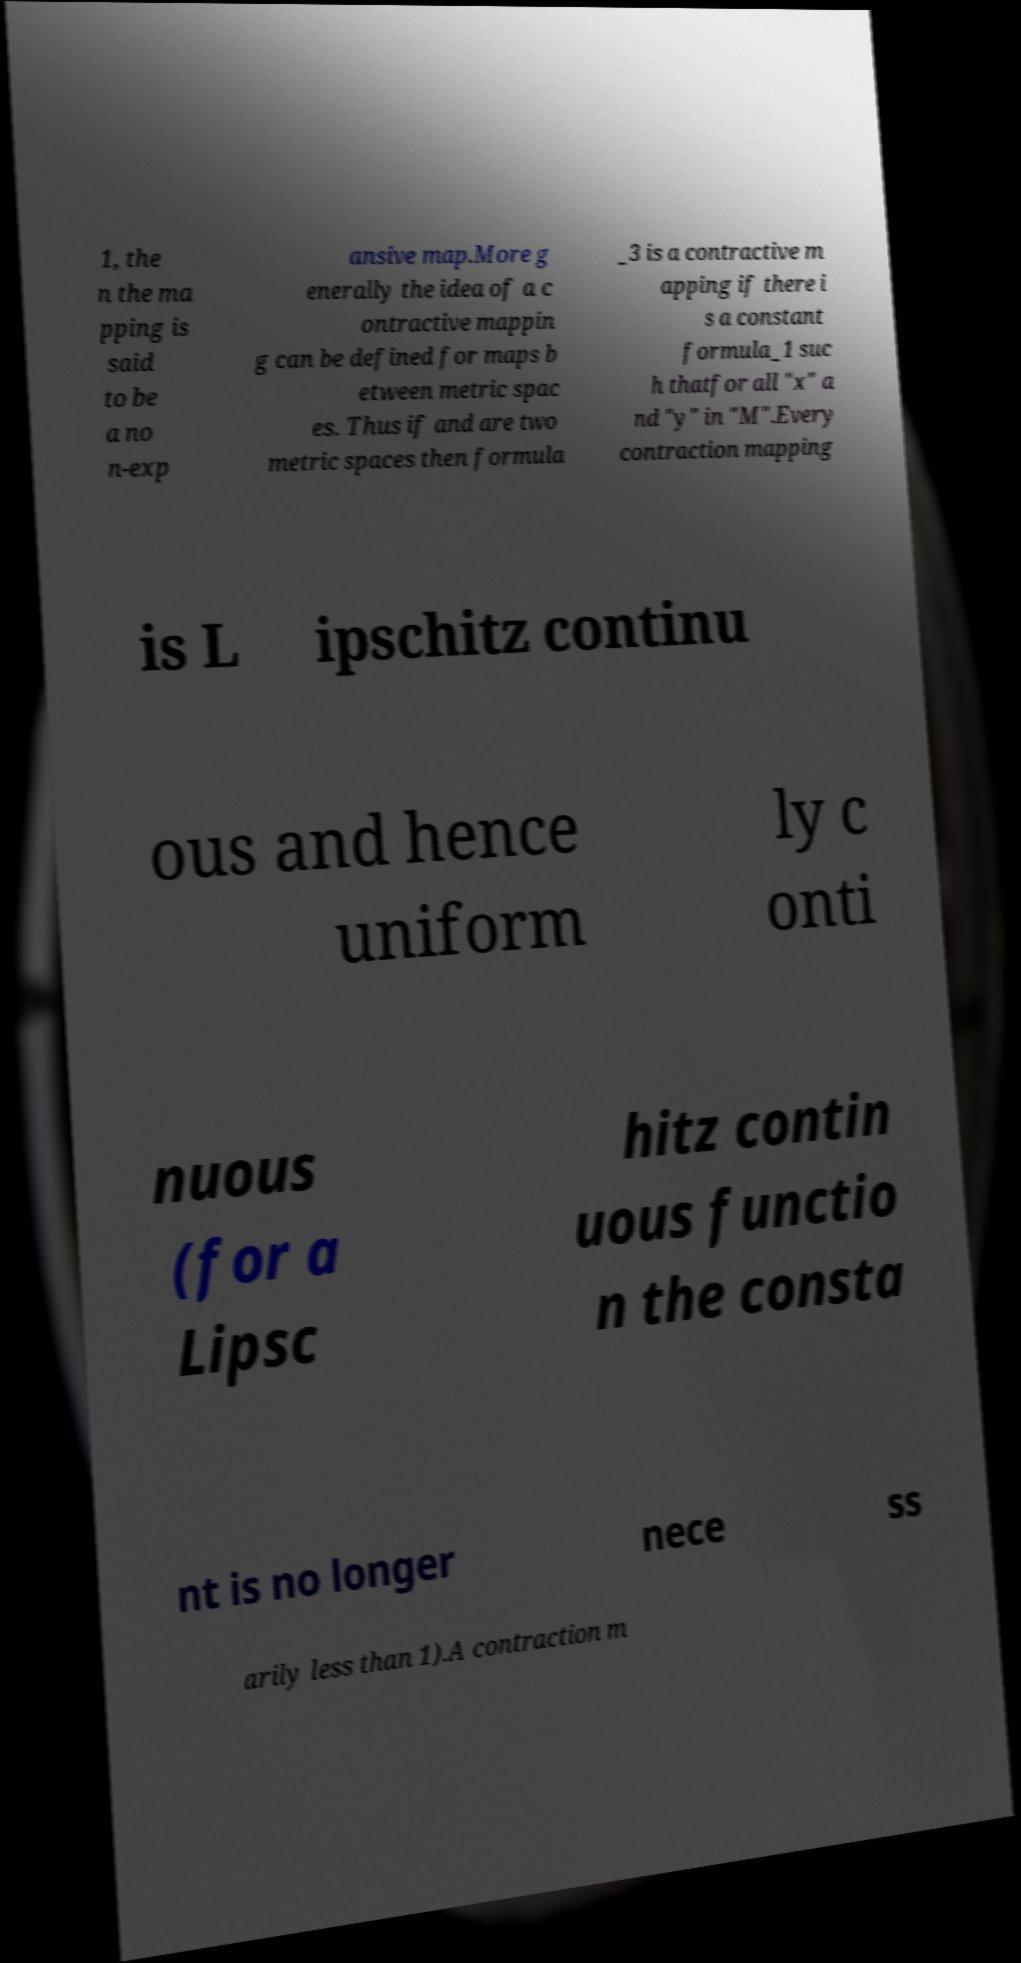There's text embedded in this image that I need extracted. Can you transcribe it verbatim? 1, the n the ma pping is said to be a no n-exp ansive map.More g enerally the idea of a c ontractive mappin g can be defined for maps b etween metric spac es. Thus if and are two metric spaces then formula _3 is a contractive m apping if there i s a constant formula_1 suc h thatfor all "x" a nd "y" in "M".Every contraction mapping is L ipschitz continu ous and hence uniform ly c onti nuous (for a Lipsc hitz contin uous functio n the consta nt is no longer nece ss arily less than 1).A contraction m 